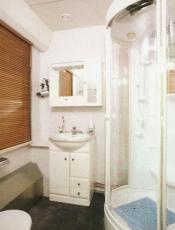Describe the objects in this image and their specific colors. I can see sink in lightgray and tan tones, toilet in lightgray, gray, and darkgray tones, and hair drier in lightgray, darkgray, and gray tones in this image. 